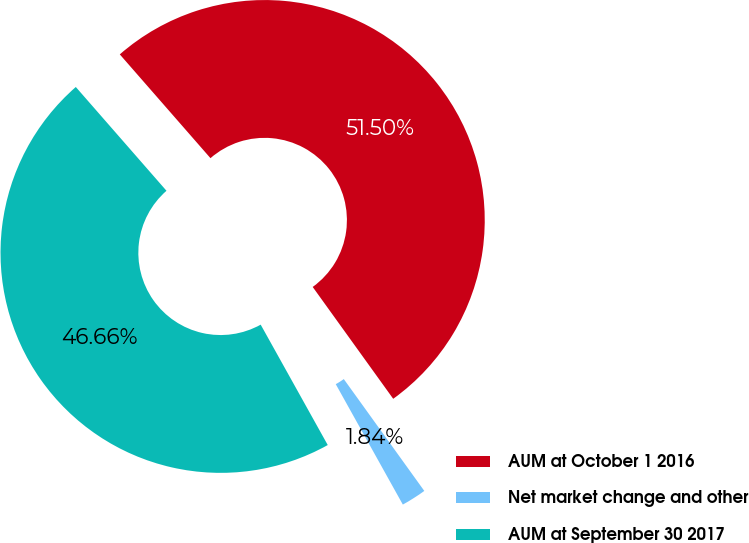Convert chart to OTSL. <chart><loc_0><loc_0><loc_500><loc_500><pie_chart><fcel>AUM at October 1 2016<fcel>Net market change and other<fcel>AUM at September 30 2017<nl><fcel>51.5%<fcel>1.84%<fcel>46.66%<nl></chart> 